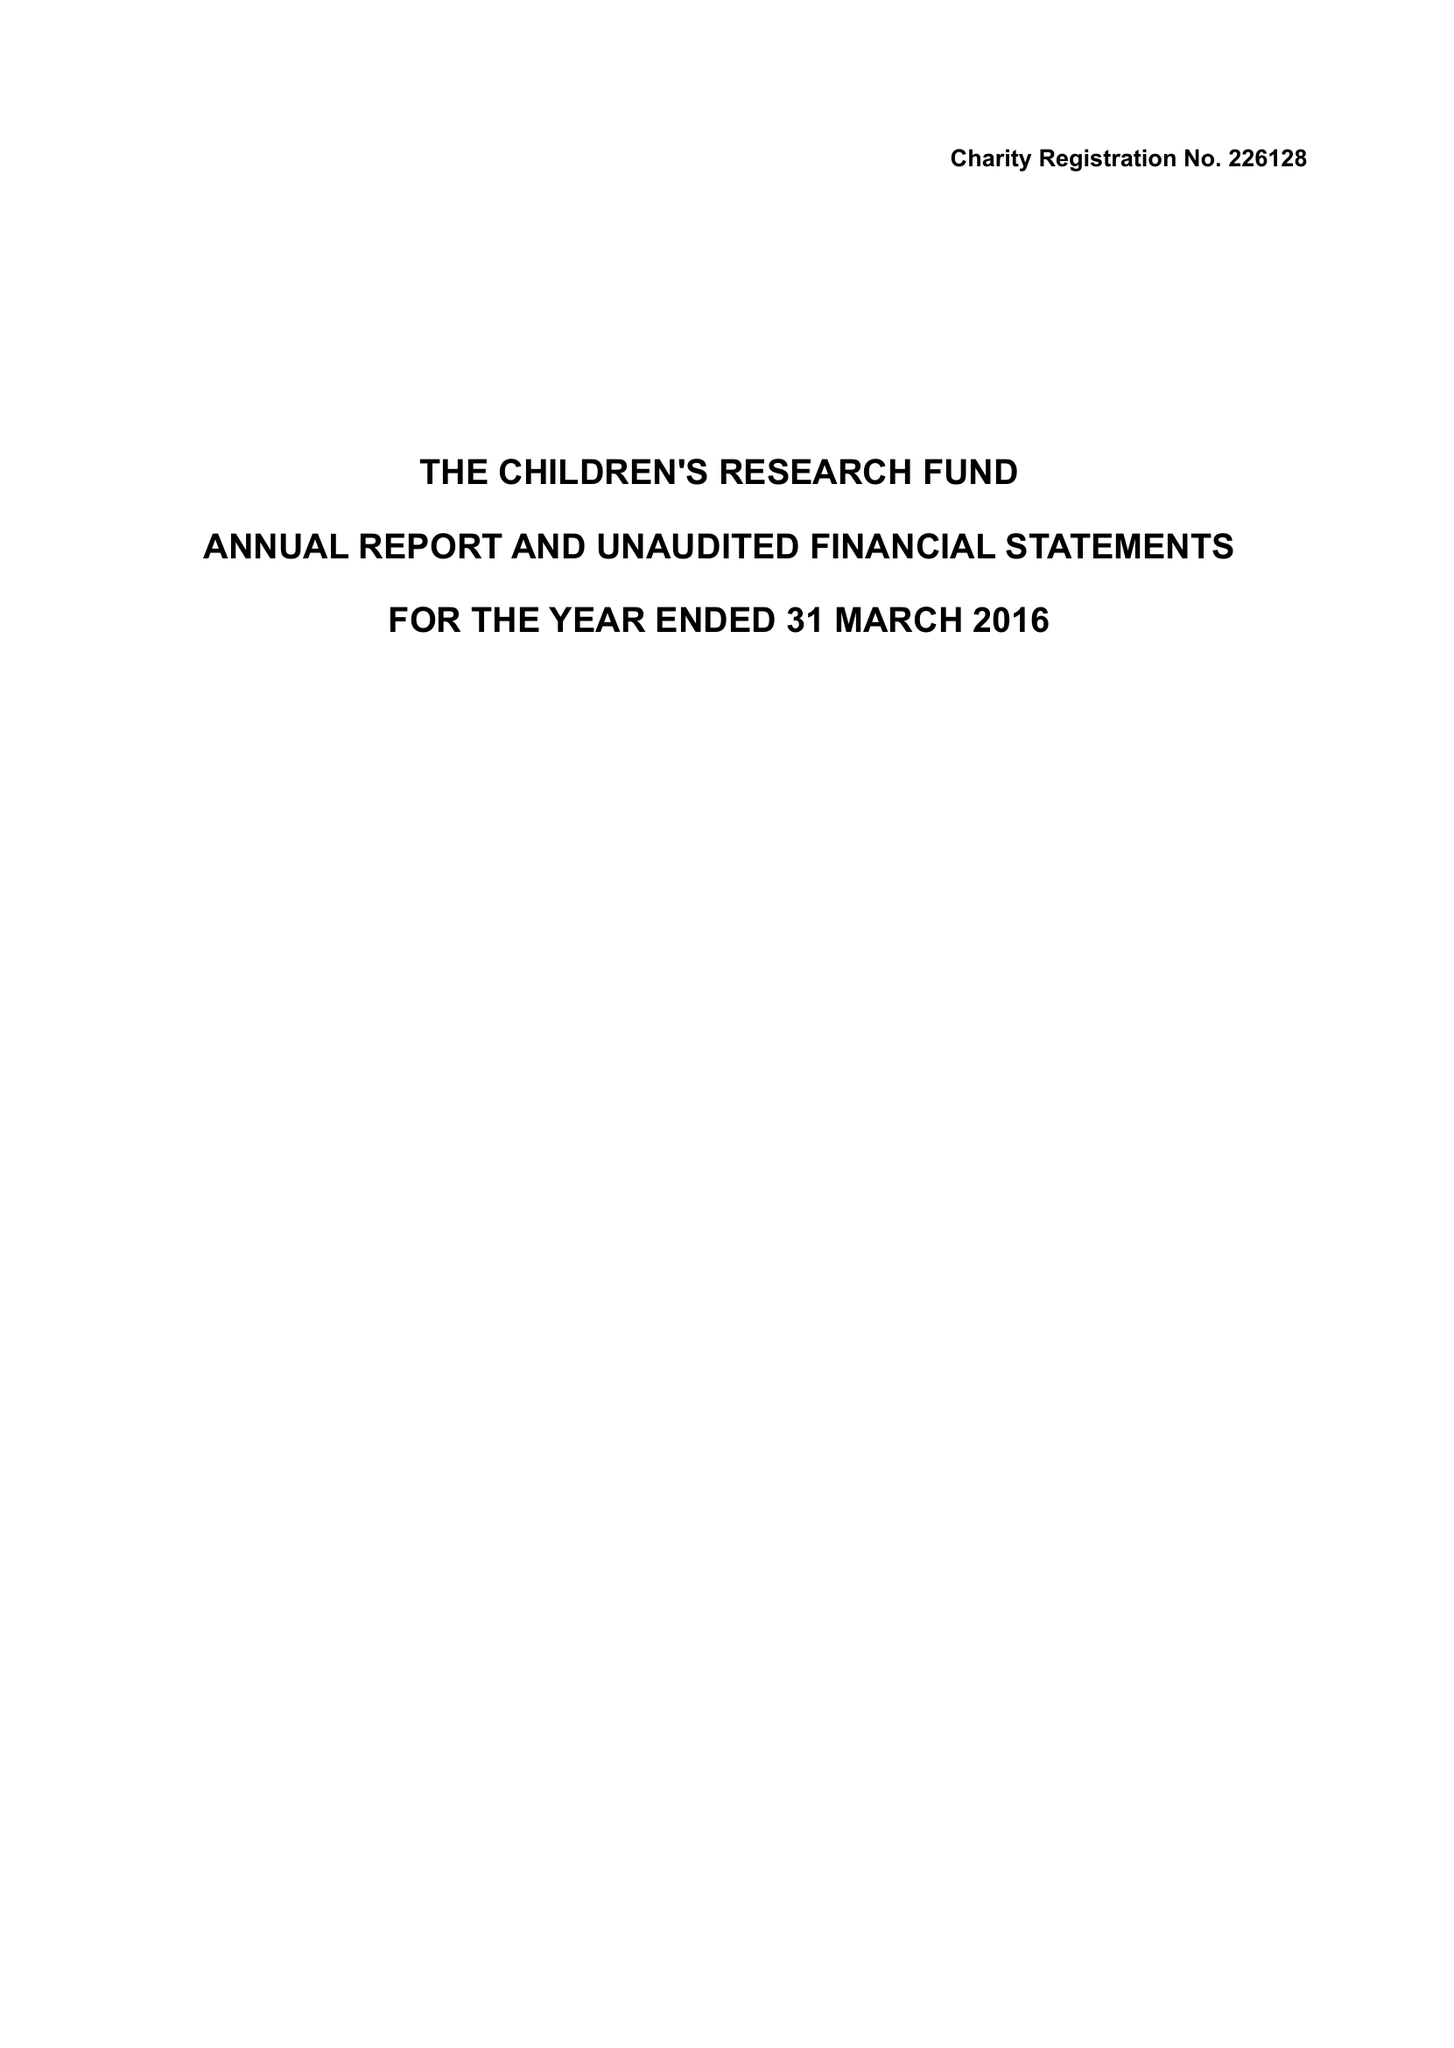What is the value for the income_annually_in_british_pounds?
Answer the question using a single word or phrase. 70468.00 